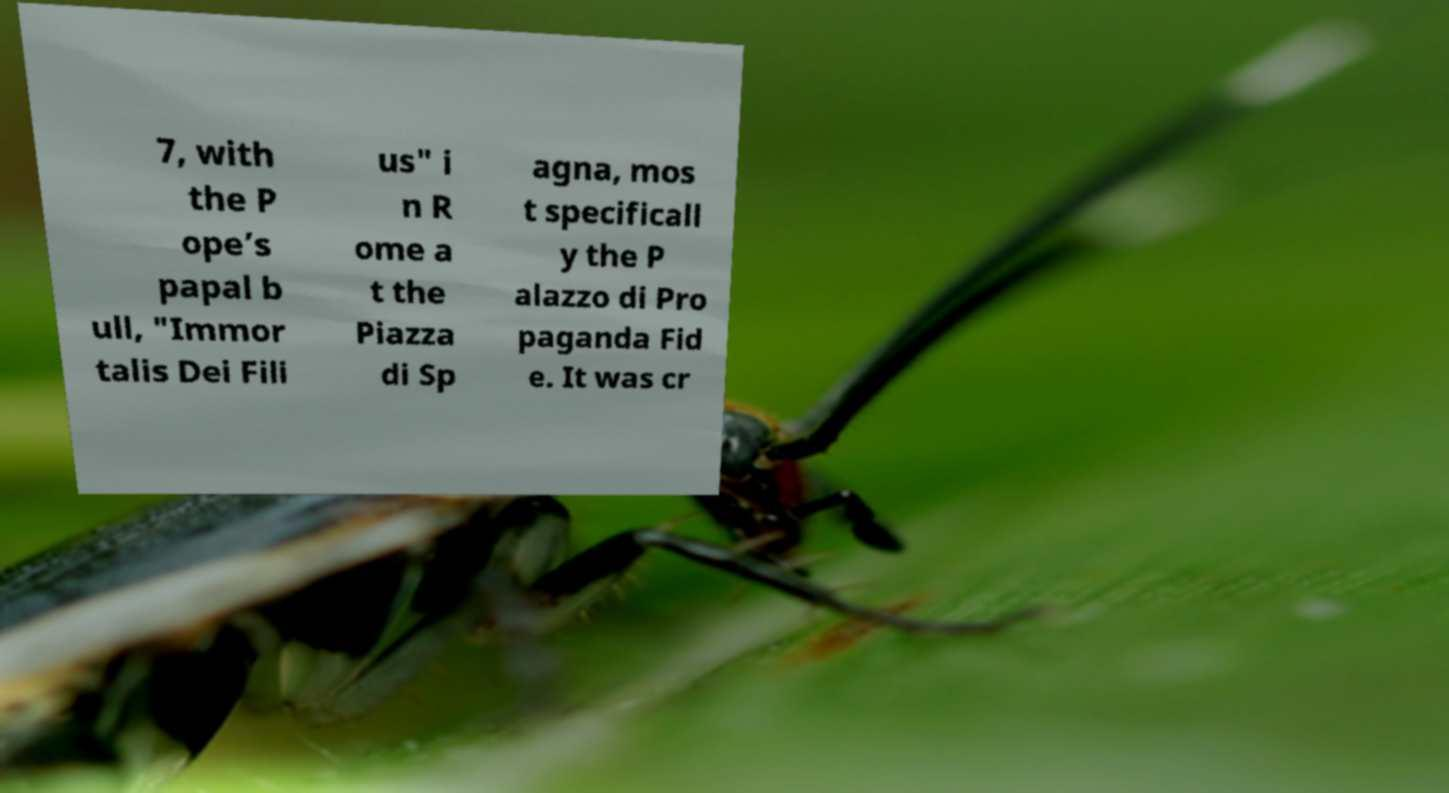Can you read and provide the text displayed in the image?This photo seems to have some interesting text. Can you extract and type it out for me? 7, with the P ope’s papal b ull, "Immor talis Dei Fili us" i n R ome a t the Piazza di Sp agna, mos t specificall y the P alazzo di Pro paganda Fid e. It was cr 